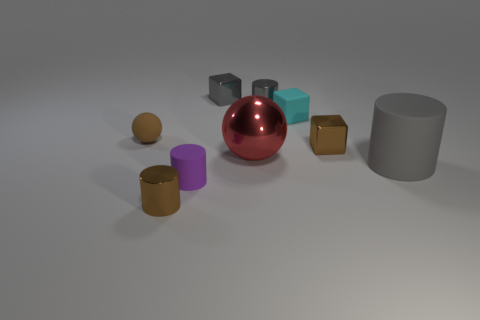There is a small rubber thing right of the red object; does it have the same color as the small matte thing that is to the left of the brown cylinder? no 